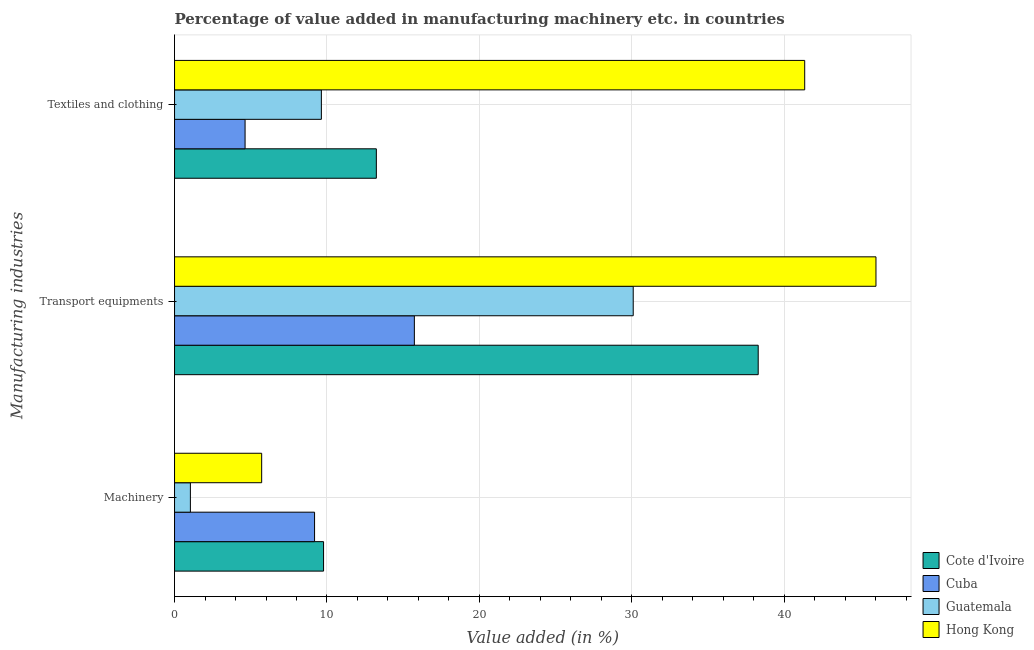How many groups of bars are there?
Provide a succinct answer. 3. Are the number of bars per tick equal to the number of legend labels?
Provide a short and direct response. Yes. Are the number of bars on each tick of the Y-axis equal?
Give a very brief answer. Yes. How many bars are there on the 3rd tick from the top?
Your answer should be very brief. 4. How many bars are there on the 3rd tick from the bottom?
Your response must be concise. 4. What is the label of the 3rd group of bars from the top?
Give a very brief answer. Machinery. What is the value added in manufacturing machinery in Hong Kong?
Make the answer very short. 5.72. Across all countries, what is the maximum value added in manufacturing transport equipments?
Your response must be concise. 46.01. Across all countries, what is the minimum value added in manufacturing machinery?
Keep it short and to the point. 1.04. In which country was the value added in manufacturing machinery maximum?
Offer a very short reply. Cote d'Ivoire. In which country was the value added in manufacturing textile and clothing minimum?
Give a very brief answer. Cuba. What is the total value added in manufacturing textile and clothing in the graph?
Give a very brief answer. 68.84. What is the difference between the value added in manufacturing machinery in Cote d'Ivoire and that in Hong Kong?
Provide a short and direct response. 4.06. What is the difference between the value added in manufacturing transport equipments in Cote d'Ivoire and the value added in manufacturing textile and clothing in Guatemala?
Ensure brevity in your answer.  28.66. What is the average value added in manufacturing textile and clothing per country?
Offer a very short reply. 17.21. What is the difference between the value added in manufacturing transport equipments and value added in manufacturing textile and clothing in Guatemala?
Ensure brevity in your answer.  20.46. What is the ratio of the value added in manufacturing textile and clothing in Hong Kong to that in Guatemala?
Provide a succinct answer. 4.29. Is the difference between the value added in manufacturing machinery in Cuba and Cote d'Ivoire greater than the difference between the value added in manufacturing textile and clothing in Cuba and Cote d'Ivoire?
Offer a very short reply. Yes. What is the difference between the highest and the second highest value added in manufacturing machinery?
Make the answer very short. 0.59. What is the difference between the highest and the lowest value added in manufacturing machinery?
Ensure brevity in your answer.  8.74. What does the 1st bar from the top in Transport equipments represents?
Make the answer very short. Hong Kong. What does the 2nd bar from the bottom in Textiles and clothing represents?
Keep it short and to the point. Cuba. How many bars are there?
Your answer should be very brief. 12. How many countries are there in the graph?
Provide a succinct answer. 4. What is the difference between two consecutive major ticks on the X-axis?
Ensure brevity in your answer.  10. Does the graph contain any zero values?
Provide a short and direct response. No. Does the graph contain grids?
Offer a terse response. Yes. Where does the legend appear in the graph?
Make the answer very short. Bottom right. How many legend labels are there?
Keep it short and to the point. 4. What is the title of the graph?
Provide a short and direct response. Percentage of value added in manufacturing machinery etc. in countries. Does "Sierra Leone" appear as one of the legend labels in the graph?
Provide a short and direct response. No. What is the label or title of the X-axis?
Provide a short and direct response. Value added (in %). What is the label or title of the Y-axis?
Your answer should be compact. Manufacturing industries. What is the Value added (in %) in Cote d'Ivoire in Machinery?
Give a very brief answer. 9.78. What is the Value added (in %) of Cuba in Machinery?
Provide a short and direct response. 9.18. What is the Value added (in %) of Guatemala in Machinery?
Offer a terse response. 1.04. What is the Value added (in %) of Hong Kong in Machinery?
Offer a terse response. 5.72. What is the Value added (in %) in Cote d'Ivoire in Transport equipments?
Offer a terse response. 38.29. What is the Value added (in %) of Cuba in Transport equipments?
Your answer should be compact. 15.73. What is the Value added (in %) of Guatemala in Transport equipments?
Provide a succinct answer. 30.09. What is the Value added (in %) of Hong Kong in Transport equipments?
Offer a terse response. 46.01. What is the Value added (in %) of Cote d'Ivoire in Textiles and clothing?
Give a very brief answer. 13.24. What is the Value added (in %) of Cuba in Textiles and clothing?
Give a very brief answer. 4.63. What is the Value added (in %) of Guatemala in Textiles and clothing?
Provide a succinct answer. 9.63. What is the Value added (in %) in Hong Kong in Textiles and clothing?
Make the answer very short. 41.34. Across all Manufacturing industries, what is the maximum Value added (in %) in Cote d'Ivoire?
Offer a terse response. 38.29. Across all Manufacturing industries, what is the maximum Value added (in %) in Cuba?
Give a very brief answer. 15.73. Across all Manufacturing industries, what is the maximum Value added (in %) of Guatemala?
Make the answer very short. 30.09. Across all Manufacturing industries, what is the maximum Value added (in %) of Hong Kong?
Your answer should be very brief. 46.01. Across all Manufacturing industries, what is the minimum Value added (in %) in Cote d'Ivoire?
Your answer should be very brief. 9.78. Across all Manufacturing industries, what is the minimum Value added (in %) in Cuba?
Give a very brief answer. 4.63. Across all Manufacturing industries, what is the minimum Value added (in %) of Guatemala?
Keep it short and to the point. 1.04. Across all Manufacturing industries, what is the minimum Value added (in %) in Hong Kong?
Offer a terse response. 5.72. What is the total Value added (in %) of Cote d'Ivoire in the graph?
Provide a short and direct response. 61.3. What is the total Value added (in %) in Cuba in the graph?
Your answer should be compact. 29.54. What is the total Value added (in %) in Guatemala in the graph?
Provide a short and direct response. 40.76. What is the total Value added (in %) of Hong Kong in the graph?
Give a very brief answer. 93.07. What is the difference between the Value added (in %) in Cote d'Ivoire in Machinery and that in Transport equipments?
Provide a succinct answer. -28.51. What is the difference between the Value added (in %) in Cuba in Machinery and that in Transport equipments?
Your answer should be very brief. -6.55. What is the difference between the Value added (in %) in Guatemala in Machinery and that in Transport equipments?
Your answer should be very brief. -29.05. What is the difference between the Value added (in %) of Hong Kong in Machinery and that in Transport equipments?
Your response must be concise. -40.3. What is the difference between the Value added (in %) of Cote d'Ivoire in Machinery and that in Textiles and clothing?
Keep it short and to the point. -3.46. What is the difference between the Value added (in %) of Cuba in Machinery and that in Textiles and clothing?
Offer a very short reply. 4.56. What is the difference between the Value added (in %) in Guatemala in Machinery and that in Textiles and clothing?
Your answer should be very brief. -8.59. What is the difference between the Value added (in %) in Hong Kong in Machinery and that in Textiles and clothing?
Keep it short and to the point. -35.62. What is the difference between the Value added (in %) in Cote d'Ivoire in Transport equipments and that in Textiles and clothing?
Your answer should be very brief. 25.05. What is the difference between the Value added (in %) in Cuba in Transport equipments and that in Textiles and clothing?
Offer a very short reply. 11.1. What is the difference between the Value added (in %) of Guatemala in Transport equipments and that in Textiles and clothing?
Your answer should be very brief. 20.46. What is the difference between the Value added (in %) in Hong Kong in Transport equipments and that in Textiles and clothing?
Your answer should be compact. 4.68. What is the difference between the Value added (in %) of Cote d'Ivoire in Machinery and the Value added (in %) of Cuba in Transport equipments?
Ensure brevity in your answer.  -5.96. What is the difference between the Value added (in %) of Cote d'Ivoire in Machinery and the Value added (in %) of Guatemala in Transport equipments?
Offer a terse response. -20.31. What is the difference between the Value added (in %) in Cote d'Ivoire in Machinery and the Value added (in %) in Hong Kong in Transport equipments?
Your answer should be very brief. -36.24. What is the difference between the Value added (in %) in Cuba in Machinery and the Value added (in %) in Guatemala in Transport equipments?
Your answer should be compact. -20.91. What is the difference between the Value added (in %) of Cuba in Machinery and the Value added (in %) of Hong Kong in Transport equipments?
Offer a very short reply. -36.83. What is the difference between the Value added (in %) in Guatemala in Machinery and the Value added (in %) in Hong Kong in Transport equipments?
Provide a short and direct response. -44.98. What is the difference between the Value added (in %) in Cote d'Ivoire in Machinery and the Value added (in %) in Cuba in Textiles and clothing?
Make the answer very short. 5.15. What is the difference between the Value added (in %) in Cote d'Ivoire in Machinery and the Value added (in %) in Guatemala in Textiles and clothing?
Provide a succinct answer. 0.14. What is the difference between the Value added (in %) in Cote d'Ivoire in Machinery and the Value added (in %) in Hong Kong in Textiles and clothing?
Your response must be concise. -31.56. What is the difference between the Value added (in %) in Cuba in Machinery and the Value added (in %) in Guatemala in Textiles and clothing?
Your answer should be compact. -0.45. What is the difference between the Value added (in %) of Cuba in Machinery and the Value added (in %) of Hong Kong in Textiles and clothing?
Offer a very short reply. -32.16. What is the difference between the Value added (in %) in Guatemala in Machinery and the Value added (in %) in Hong Kong in Textiles and clothing?
Keep it short and to the point. -40.3. What is the difference between the Value added (in %) of Cote d'Ivoire in Transport equipments and the Value added (in %) of Cuba in Textiles and clothing?
Your response must be concise. 33.66. What is the difference between the Value added (in %) in Cote d'Ivoire in Transport equipments and the Value added (in %) in Guatemala in Textiles and clothing?
Offer a terse response. 28.66. What is the difference between the Value added (in %) of Cote d'Ivoire in Transport equipments and the Value added (in %) of Hong Kong in Textiles and clothing?
Give a very brief answer. -3.05. What is the difference between the Value added (in %) of Cuba in Transport equipments and the Value added (in %) of Guatemala in Textiles and clothing?
Your response must be concise. 6.1. What is the difference between the Value added (in %) of Cuba in Transport equipments and the Value added (in %) of Hong Kong in Textiles and clothing?
Provide a succinct answer. -25.61. What is the difference between the Value added (in %) in Guatemala in Transport equipments and the Value added (in %) in Hong Kong in Textiles and clothing?
Offer a very short reply. -11.25. What is the average Value added (in %) in Cote d'Ivoire per Manufacturing industries?
Provide a short and direct response. 20.43. What is the average Value added (in %) in Cuba per Manufacturing industries?
Offer a very short reply. 9.85. What is the average Value added (in %) in Guatemala per Manufacturing industries?
Make the answer very short. 13.59. What is the average Value added (in %) of Hong Kong per Manufacturing industries?
Make the answer very short. 31.02. What is the difference between the Value added (in %) of Cote d'Ivoire and Value added (in %) of Cuba in Machinery?
Your response must be concise. 0.59. What is the difference between the Value added (in %) in Cote d'Ivoire and Value added (in %) in Guatemala in Machinery?
Make the answer very short. 8.74. What is the difference between the Value added (in %) of Cote d'Ivoire and Value added (in %) of Hong Kong in Machinery?
Keep it short and to the point. 4.06. What is the difference between the Value added (in %) of Cuba and Value added (in %) of Guatemala in Machinery?
Make the answer very short. 8.15. What is the difference between the Value added (in %) in Cuba and Value added (in %) in Hong Kong in Machinery?
Make the answer very short. 3.47. What is the difference between the Value added (in %) in Guatemala and Value added (in %) in Hong Kong in Machinery?
Your answer should be very brief. -4.68. What is the difference between the Value added (in %) of Cote d'Ivoire and Value added (in %) of Cuba in Transport equipments?
Give a very brief answer. 22.56. What is the difference between the Value added (in %) of Cote d'Ivoire and Value added (in %) of Guatemala in Transport equipments?
Your answer should be very brief. 8.2. What is the difference between the Value added (in %) in Cote d'Ivoire and Value added (in %) in Hong Kong in Transport equipments?
Your response must be concise. -7.73. What is the difference between the Value added (in %) in Cuba and Value added (in %) in Guatemala in Transport equipments?
Keep it short and to the point. -14.36. What is the difference between the Value added (in %) of Cuba and Value added (in %) of Hong Kong in Transport equipments?
Provide a succinct answer. -30.28. What is the difference between the Value added (in %) in Guatemala and Value added (in %) in Hong Kong in Transport equipments?
Make the answer very short. -15.92. What is the difference between the Value added (in %) in Cote d'Ivoire and Value added (in %) in Cuba in Textiles and clothing?
Make the answer very short. 8.61. What is the difference between the Value added (in %) of Cote d'Ivoire and Value added (in %) of Guatemala in Textiles and clothing?
Offer a terse response. 3.61. What is the difference between the Value added (in %) of Cote d'Ivoire and Value added (in %) of Hong Kong in Textiles and clothing?
Provide a succinct answer. -28.1. What is the difference between the Value added (in %) of Cuba and Value added (in %) of Guatemala in Textiles and clothing?
Your answer should be very brief. -5.01. What is the difference between the Value added (in %) in Cuba and Value added (in %) in Hong Kong in Textiles and clothing?
Make the answer very short. -36.71. What is the difference between the Value added (in %) in Guatemala and Value added (in %) in Hong Kong in Textiles and clothing?
Keep it short and to the point. -31.71. What is the ratio of the Value added (in %) of Cote d'Ivoire in Machinery to that in Transport equipments?
Provide a succinct answer. 0.26. What is the ratio of the Value added (in %) of Cuba in Machinery to that in Transport equipments?
Provide a succinct answer. 0.58. What is the ratio of the Value added (in %) in Guatemala in Machinery to that in Transport equipments?
Offer a very short reply. 0.03. What is the ratio of the Value added (in %) of Hong Kong in Machinery to that in Transport equipments?
Your response must be concise. 0.12. What is the ratio of the Value added (in %) of Cote d'Ivoire in Machinery to that in Textiles and clothing?
Your answer should be compact. 0.74. What is the ratio of the Value added (in %) in Cuba in Machinery to that in Textiles and clothing?
Offer a very short reply. 1.99. What is the ratio of the Value added (in %) in Guatemala in Machinery to that in Textiles and clothing?
Give a very brief answer. 0.11. What is the ratio of the Value added (in %) in Hong Kong in Machinery to that in Textiles and clothing?
Offer a very short reply. 0.14. What is the ratio of the Value added (in %) in Cote d'Ivoire in Transport equipments to that in Textiles and clothing?
Your answer should be very brief. 2.89. What is the ratio of the Value added (in %) in Cuba in Transport equipments to that in Textiles and clothing?
Provide a short and direct response. 3.4. What is the ratio of the Value added (in %) in Guatemala in Transport equipments to that in Textiles and clothing?
Ensure brevity in your answer.  3.12. What is the ratio of the Value added (in %) in Hong Kong in Transport equipments to that in Textiles and clothing?
Make the answer very short. 1.11. What is the difference between the highest and the second highest Value added (in %) in Cote d'Ivoire?
Your response must be concise. 25.05. What is the difference between the highest and the second highest Value added (in %) in Cuba?
Your answer should be very brief. 6.55. What is the difference between the highest and the second highest Value added (in %) in Guatemala?
Your answer should be very brief. 20.46. What is the difference between the highest and the second highest Value added (in %) of Hong Kong?
Keep it short and to the point. 4.68. What is the difference between the highest and the lowest Value added (in %) of Cote d'Ivoire?
Keep it short and to the point. 28.51. What is the difference between the highest and the lowest Value added (in %) in Cuba?
Ensure brevity in your answer.  11.1. What is the difference between the highest and the lowest Value added (in %) in Guatemala?
Provide a succinct answer. 29.05. What is the difference between the highest and the lowest Value added (in %) in Hong Kong?
Offer a very short reply. 40.3. 